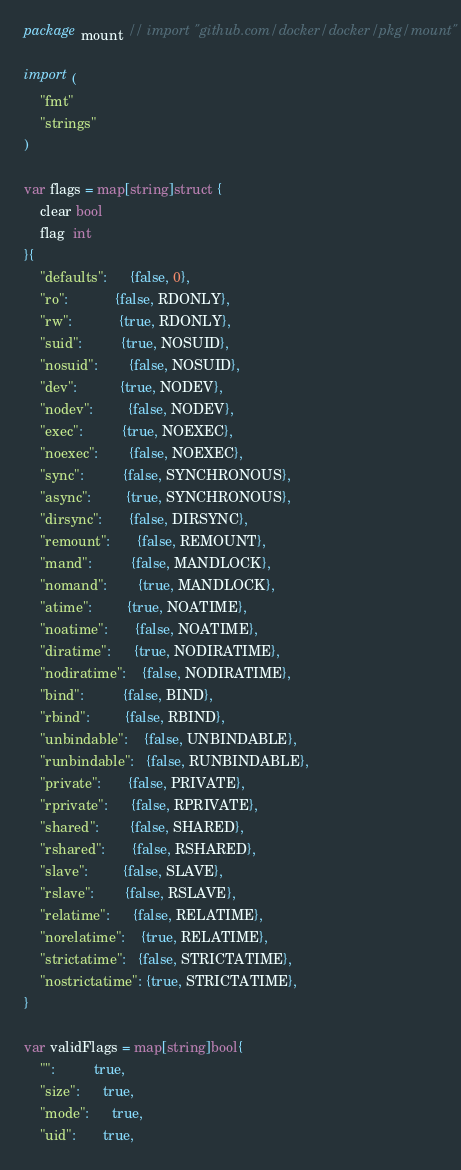<code> <loc_0><loc_0><loc_500><loc_500><_Go_>package mount // import "github.com/docker/docker/pkg/mount"

import (
	"fmt"
	"strings"
)

var flags = map[string]struct {
	clear bool
	flag  int
}{
	"defaults":      {false, 0},
	"ro":            {false, RDONLY},
	"rw":            {true, RDONLY},
	"suid":          {true, NOSUID},
	"nosuid":        {false, NOSUID},
	"dev":           {true, NODEV},
	"nodev":         {false, NODEV},
	"exec":          {true, NOEXEC},
	"noexec":        {false, NOEXEC},
	"sync":          {false, SYNCHRONOUS},
	"async":         {true, SYNCHRONOUS},
	"dirsync":       {false, DIRSYNC},
	"remount":       {false, REMOUNT},
	"mand":          {false, MANDLOCK},
	"nomand":        {true, MANDLOCK},
	"atime":         {true, NOATIME},
	"noatime":       {false, NOATIME},
	"diratime":      {true, NODIRATIME},
	"nodiratime":    {false, NODIRATIME},
	"bind":          {false, BIND},
	"rbind":         {false, RBIND},
	"unbindable":    {false, UNBINDABLE},
	"runbindable":   {false, RUNBINDABLE},
	"private":       {false, PRIVATE},
	"rprivate":      {false, RPRIVATE},
	"shared":        {false, SHARED},
	"rshared":       {false, RSHARED},
	"slave":         {false, SLAVE},
	"rslave":        {false, RSLAVE},
	"relatime":      {false, RELATIME},
	"norelatime":    {true, RELATIME},
	"strictatime":   {false, STRICTATIME},
	"nostrictatime": {true, STRICTATIME},
}

var validFlags = map[string]bool{
	"":          true,
	"size":      true,
	"mode":      true,
	"uid":       true,</code> 